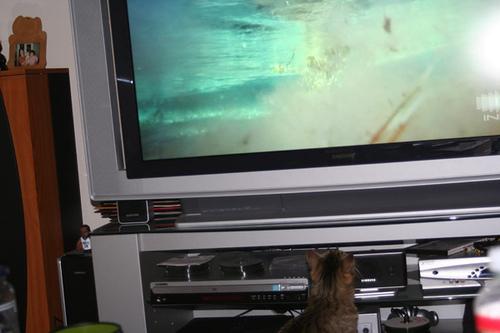Does the cat have stripes?
Short answer required. Yes. Is this an HDTV?
Answer briefly. No. Is the television on?
Short answer required. Yes. 